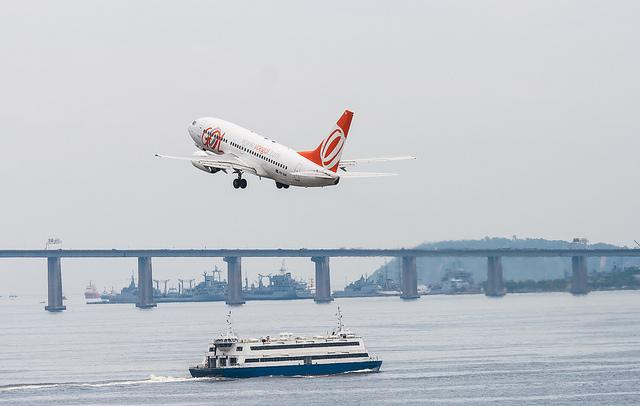What is the plane hovering over? boat 